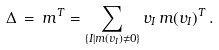<formula> <loc_0><loc_0><loc_500><loc_500>\Delta \, = \, m ^ { T } & = \sum _ { \{ I | m ( v _ { I } ) \not = 0 \} } v _ { I } \, m ( v _ { I } ) ^ { T } \, .</formula> 